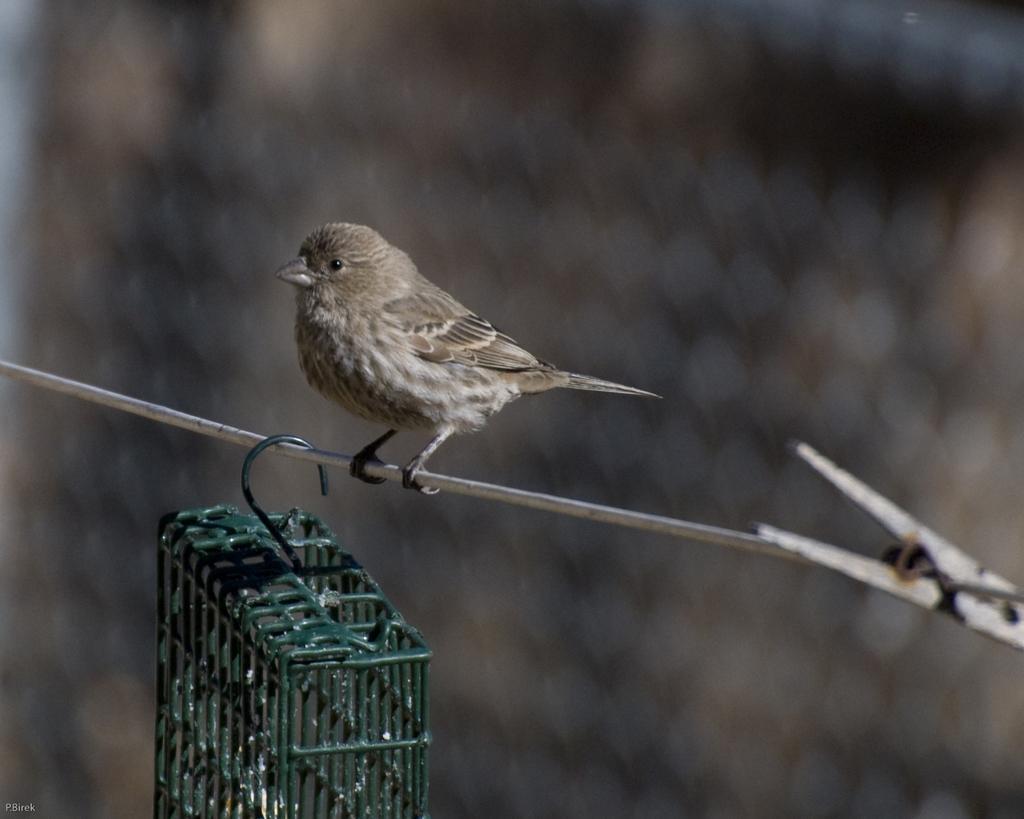In one or two sentences, can you explain what this image depicts? In this picture we can see a bird on a wire,below the wire we can see a cage and in the background we can see it is blurry. 